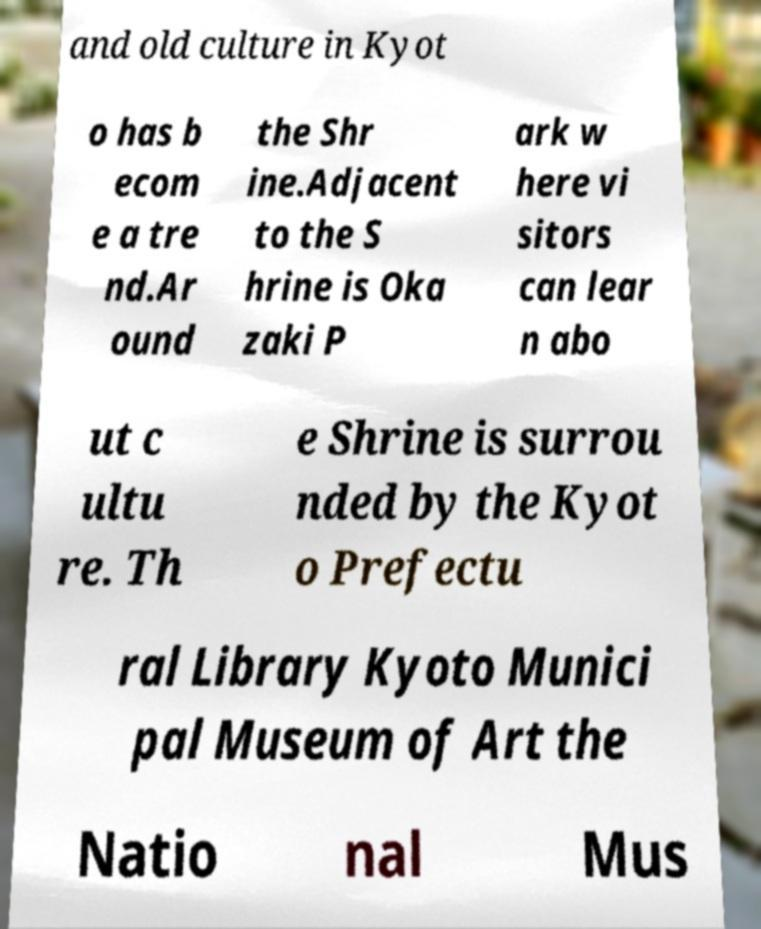Can you accurately transcribe the text from the provided image for me? and old culture in Kyot o has b ecom e a tre nd.Ar ound the Shr ine.Adjacent to the S hrine is Oka zaki P ark w here vi sitors can lear n abo ut c ultu re. Th e Shrine is surrou nded by the Kyot o Prefectu ral Library Kyoto Munici pal Museum of Art the Natio nal Mus 